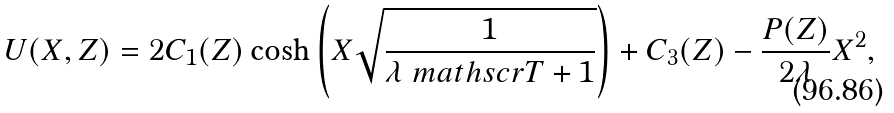<formula> <loc_0><loc_0><loc_500><loc_500>U ( X , Z ) = 2 C _ { 1 } ( Z ) \cosh \left ( X \sqrt { \frac { 1 } { \lambda \ m a t h s c r { T } + 1 } } \right ) + C _ { 3 } ( Z ) - \frac { P ( Z ) } { 2 \lambda } X ^ { 2 } ,</formula> 